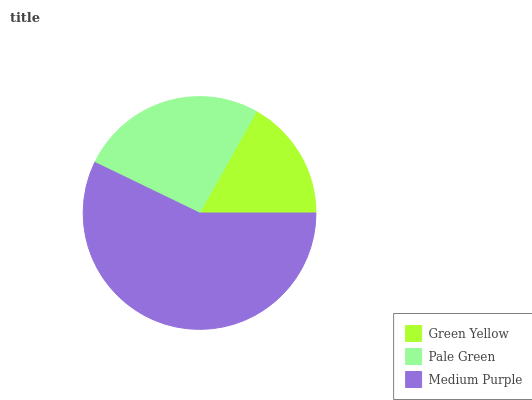Is Green Yellow the minimum?
Answer yes or no. Yes. Is Medium Purple the maximum?
Answer yes or no. Yes. Is Pale Green the minimum?
Answer yes or no. No. Is Pale Green the maximum?
Answer yes or no. No. Is Pale Green greater than Green Yellow?
Answer yes or no. Yes. Is Green Yellow less than Pale Green?
Answer yes or no. Yes. Is Green Yellow greater than Pale Green?
Answer yes or no. No. Is Pale Green less than Green Yellow?
Answer yes or no. No. Is Pale Green the high median?
Answer yes or no. Yes. Is Pale Green the low median?
Answer yes or no. Yes. Is Medium Purple the high median?
Answer yes or no. No. Is Green Yellow the low median?
Answer yes or no. No. 